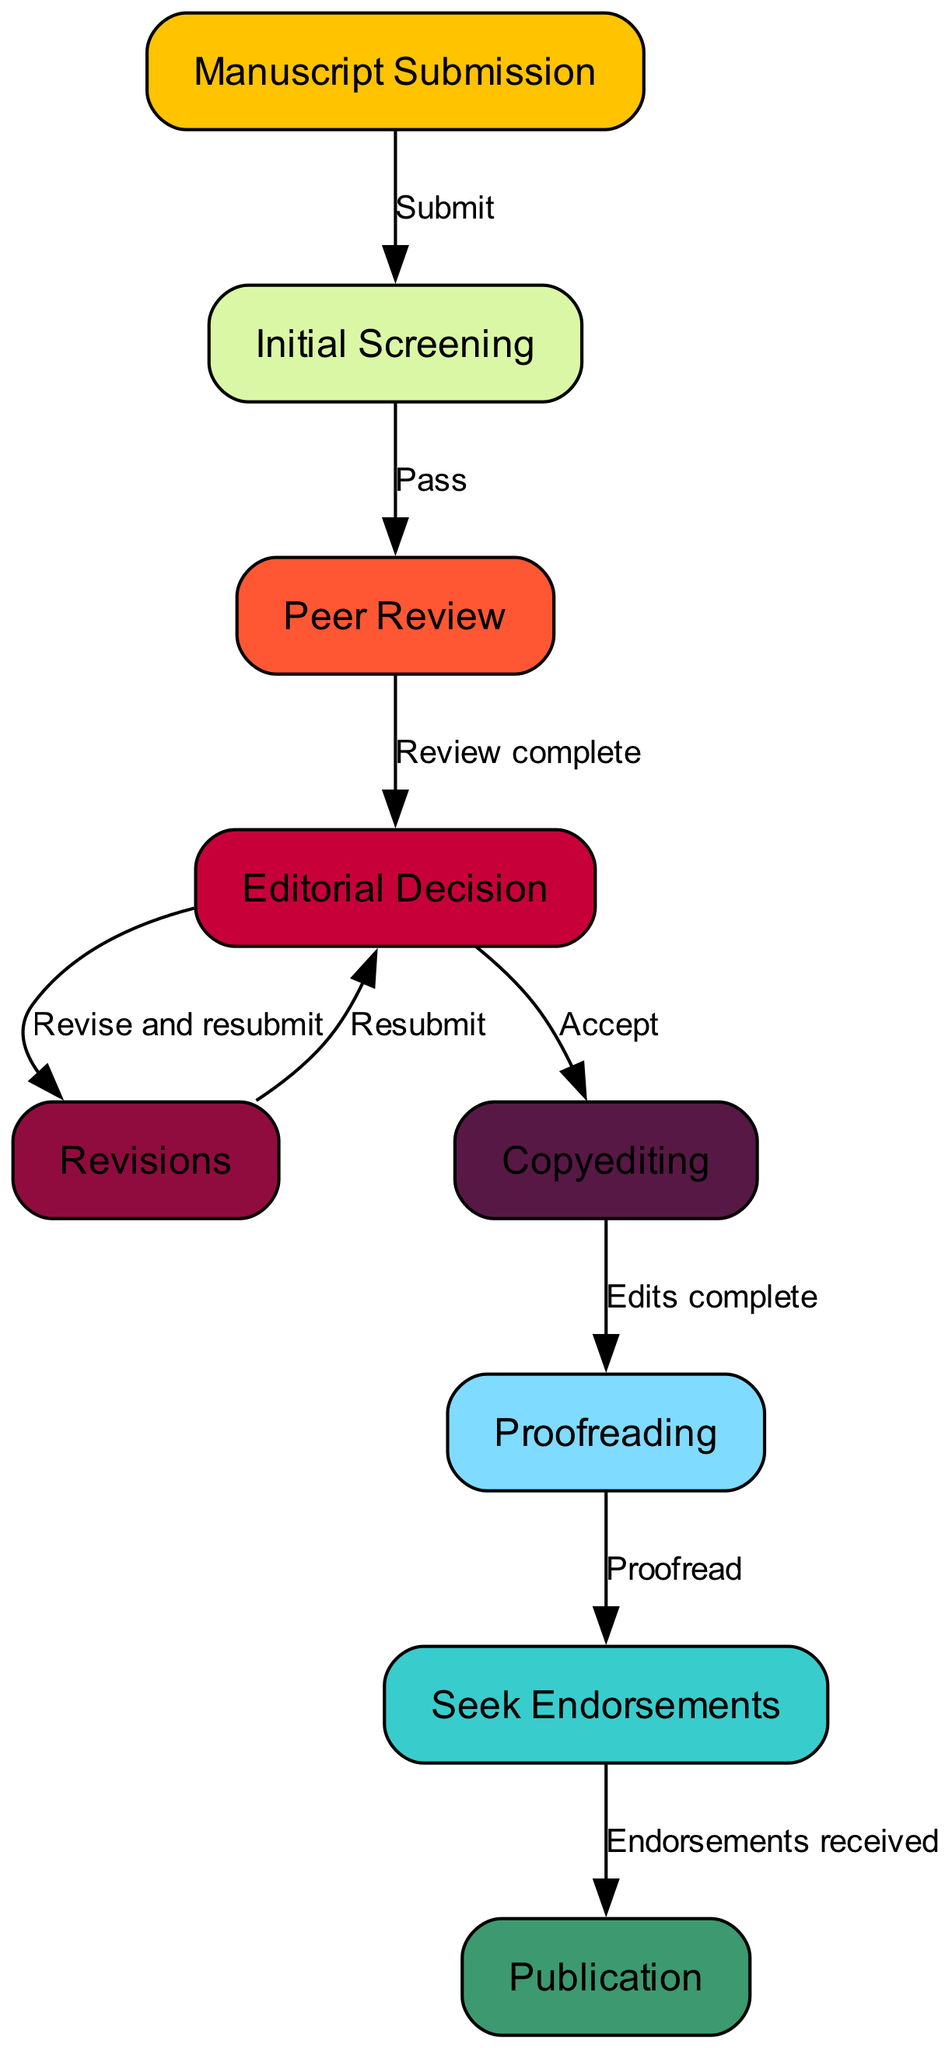What is the first step in the editorial process? The first step, according to the diagram, is "Manuscript Submission," which is the starting point for the editorial process.
Answer: Manuscript Submission How many nodes are there in total? By counting all the nodes listed in the diagram, we see that there are nine nodes total that represent various stages in the editorial process.
Answer: 9 What happens after "Initial Screening" if the manuscript passes? If the manuscript passes the "Initial Screening," it moves on to the "Peer Review" stage, where it is evaluated by experts.
Answer: Peer Review What is the outcome of the "Editorial Decision" if the manuscript is accepted? If the manuscript is accepted at the "Editorial Decision" stage, it proceeds to "Copyediting," where it undergoes formatting and corrections.
Answer: Copyediting What is the final step before publication? The final step before publication, as shown in the diagram, is to "Seek Endorsements," which involves obtaining support or approval from others for the manuscript.
Answer: Seek Endorsements If a manuscript requires revisions, what is the next step after the "Editorial Decision"? If a manuscript requires revisions after the "Editorial Decision," the author is instructed to "Revise and resubmit," indicating that changes are needed before it can be reconsidered for publication.
Answer: Revise and resubmit What action is taken after "Proofreading"? Once "Proofreading" is complete and the necessary changes have been made, the manuscript can then proceed to "Publication," marking the final point of the process.
Answer: Publication What stage follows "Revisions" if the manuscript is resubmitted? If the manuscript is resubmitted after revisions, it returns to the "Editorial Decision" stage for further evaluation and potential acceptance or additional revisions.
Answer: Editorial Decision 